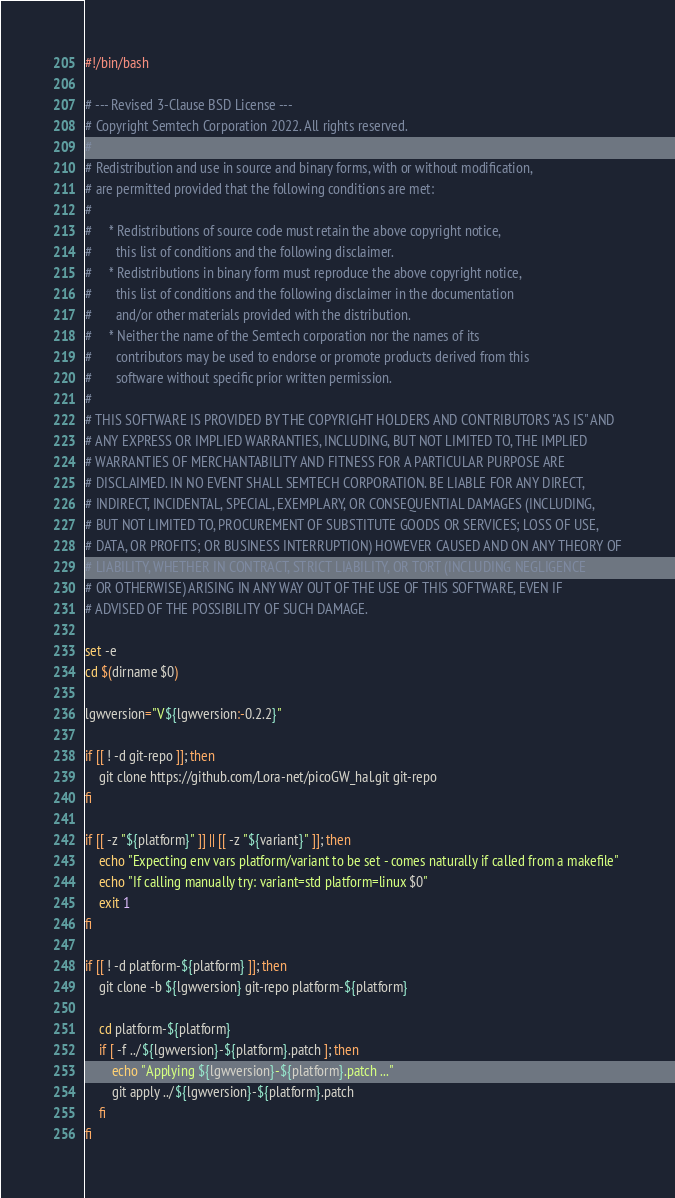Convert code to text. <code><loc_0><loc_0><loc_500><loc_500><_Bash_>#!/bin/bash

# --- Revised 3-Clause BSD License ---
# Copyright Semtech Corporation 2022. All rights reserved.
#
# Redistribution and use in source and binary forms, with or without modification,
# are permitted provided that the following conditions are met:
#
#     * Redistributions of source code must retain the above copyright notice,
#       this list of conditions and the following disclaimer.
#     * Redistributions in binary form must reproduce the above copyright notice,
#       this list of conditions and the following disclaimer in the documentation
#       and/or other materials provided with the distribution.
#     * Neither the name of the Semtech corporation nor the names of its
#       contributors may be used to endorse or promote products derived from this
#       software without specific prior written permission.
#
# THIS SOFTWARE IS PROVIDED BY THE COPYRIGHT HOLDERS AND CONTRIBUTORS "AS IS" AND
# ANY EXPRESS OR IMPLIED WARRANTIES, INCLUDING, BUT NOT LIMITED TO, THE IMPLIED
# WARRANTIES OF MERCHANTABILITY AND FITNESS FOR A PARTICULAR PURPOSE ARE
# DISCLAIMED. IN NO EVENT SHALL SEMTECH CORPORATION. BE LIABLE FOR ANY DIRECT,
# INDIRECT, INCIDENTAL, SPECIAL, EXEMPLARY, OR CONSEQUENTIAL DAMAGES (INCLUDING,
# BUT NOT LIMITED TO, PROCUREMENT OF SUBSTITUTE GOODS OR SERVICES; LOSS OF USE,
# DATA, OR PROFITS; OR BUSINESS INTERRUPTION) HOWEVER CAUSED AND ON ANY THEORY OF
# LIABILITY, WHETHER IN CONTRACT, STRICT LIABILITY, OR TORT (INCLUDING NEGLIGENCE
# OR OTHERWISE) ARISING IN ANY WAY OUT OF THE USE OF THIS SOFTWARE, EVEN IF
# ADVISED OF THE POSSIBILITY OF SUCH DAMAGE.

set -e
cd $(dirname $0)

lgwversion="V${lgwversion:-0.2.2}"

if [[ ! -d git-repo ]]; then
    git clone https://github.com/Lora-net/picoGW_hal.git git-repo
fi

if [[ -z "${platform}" ]] || [[ -z "${variant}" ]]; then
    echo "Expecting env vars platform/variant to be set - comes naturally if called from a makefile"
    echo "If calling manually try: variant=std platform=linux $0"
    exit 1
fi

if [[ ! -d platform-${platform} ]]; then
    git clone -b ${lgwversion} git-repo platform-${platform}

    cd platform-${platform}
    if [ -f ../${lgwversion}-${platform}.patch ]; then
        echo "Applying ${lgwversion}-${platform}.patch ..."
        git apply ../${lgwversion}-${platform}.patch
    fi
fi
</code> 